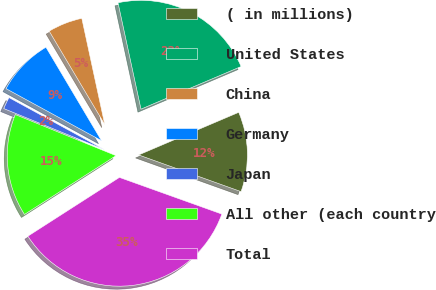Convert chart. <chart><loc_0><loc_0><loc_500><loc_500><pie_chart><fcel>( in millions)<fcel>United States<fcel>China<fcel>Germany<fcel>Japan<fcel>All other (each country<fcel>Total<nl><fcel>11.88%<fcel>21.98%<fcel>5.15%<fcel>8.52%<fcel>1.78%<fcel>15.25%<fcel>35.44%<nl></chart> 